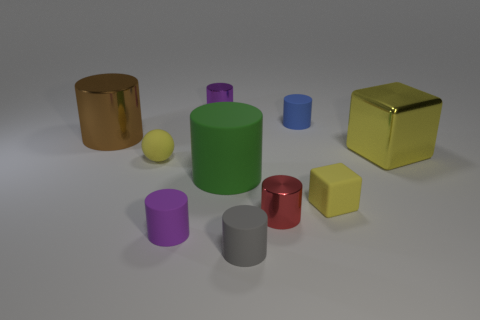The thing that is to the right of the blue rubber cylinder and in front of the large rubber object is made of what material?
Your response must be concise. Rubber. What number of blue objects have the same shape as the tiny purple matte object?
Ensure brevity in your answer.  1. There is a rubber cylinder that is to the left of the tiny purple cylinder that is behind the large metallic cube; what is its size?
Give a very brief answer. Small. There is a tiny metal cylinder in front of the green matte cylinder; is it the same color as the tiny metallic cylinder behind the tiny red cylinder?
Make the answer very short. No. How many small things are behind the purple cylinder that is in front of the tiny metal cylinder in front of the purple metal object?
Ensure brevity in your answer.  5. What number of objects are both to the left of the red object and in front of the large brown metallic thing?
Offer a very short reply. 4. Is the number of tiny red objects that are behind the small block greater than the number of large objects?
Offer a terse response. No. What number of yellow blocks are the same size as the red metallic cylinder?
Provide a short and direct response. 1. There is a rubber block that is the same color as the rubber ball; what size is it?
Your answer should be very brief. Small. How many small things are yellow metal blocks or matte cylinders?
Give a very brief answer. 3. 